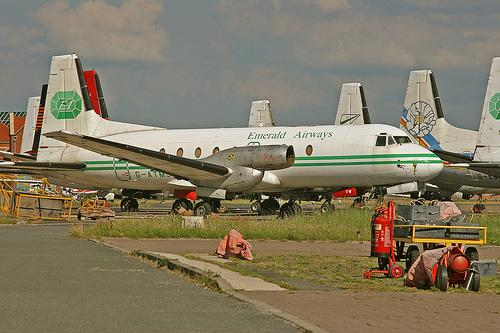What elements of the image hint at the location or setting? The grassy area, asphalt road, multiple plane tails, and open sky suggest an airport or airplane hangar setting. What kind of special objects or equipment can you find in this image? A yellow metal cart for supplies, red fire extinguisher, and red pressure tank near the airplane. If you were writing an Instagram caption for this image, what would it be? ✈️ Majestic Emerald Airways plane soaking in the sunlight! ☘️💎 #EmeraldAirways #PlaneSpotting List three key elements found in the photo. White and green Emerald Airways airplane, multiple plane tails in the background, grassy area beside the plane. Write a poetic caption about the content of the photo. Where sky and earth collide, the emerald bird soars. Describe the environment where the main subject is placed. The main subject, an Emerald Airways plane, is surrounded by a grassy area, a road with asphalt, and an open sky. A story inspired by this image Emerald Airways unveiled their latest fleet addition, a magnificent white and green aircraft, as enthusiasts gathered to witness the tails of multiple planes lined up against a clear blue sky. Comment on the background of the image. The image has a beautiful open sky backdrop, with four plane tails in the distance, creating a captivating sight. Elaborate on the color and appearance of the main subject in the image. The main subject is a sleek, white airplane featuring green stripes and the Emerald Airways logo, with a glimpse of clear cockpit windows. Provide a brief description of what you see in the image. A large white and green Emerald Airways airplane is parked beside a grassy area, with multiple plane tails visible in the background. 